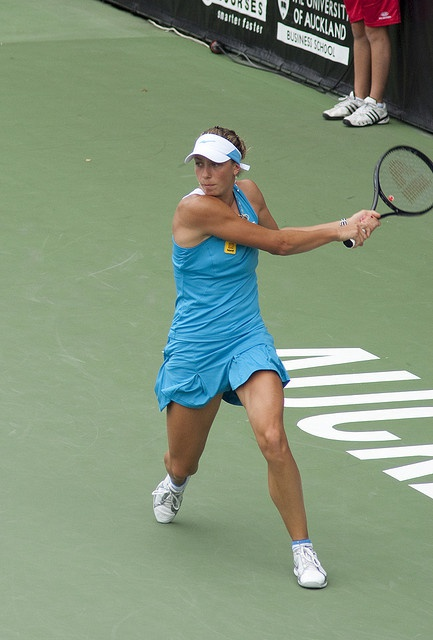Describe the objects in this image and their specific colors. I can see people in darkgray, gray, lightblue, and teal tones, people in darkgray, gray, maroon, and brown tones, and tennis racket in darkgray, gray, and black tones in this image. 